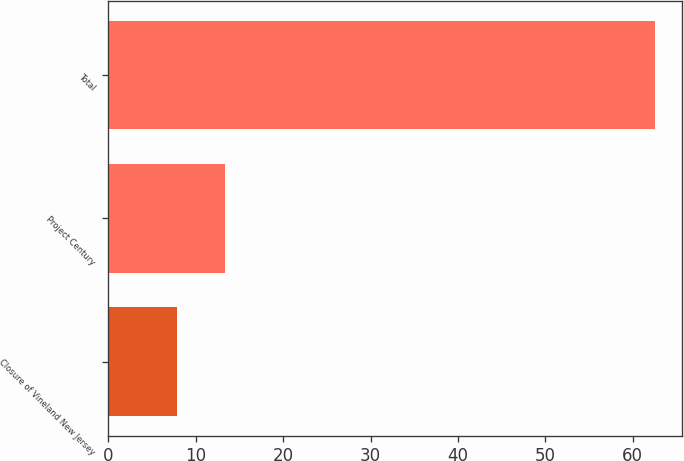<chart> <loc_0><loc_0><loc_500><loc_500><bar_chart><fcel>Closure of Vineland New Jersey<fcel>Project Century<fcel>Total<nl><fcel>7.9<fcel>13.36<fcel>62.5<nl></chart> 